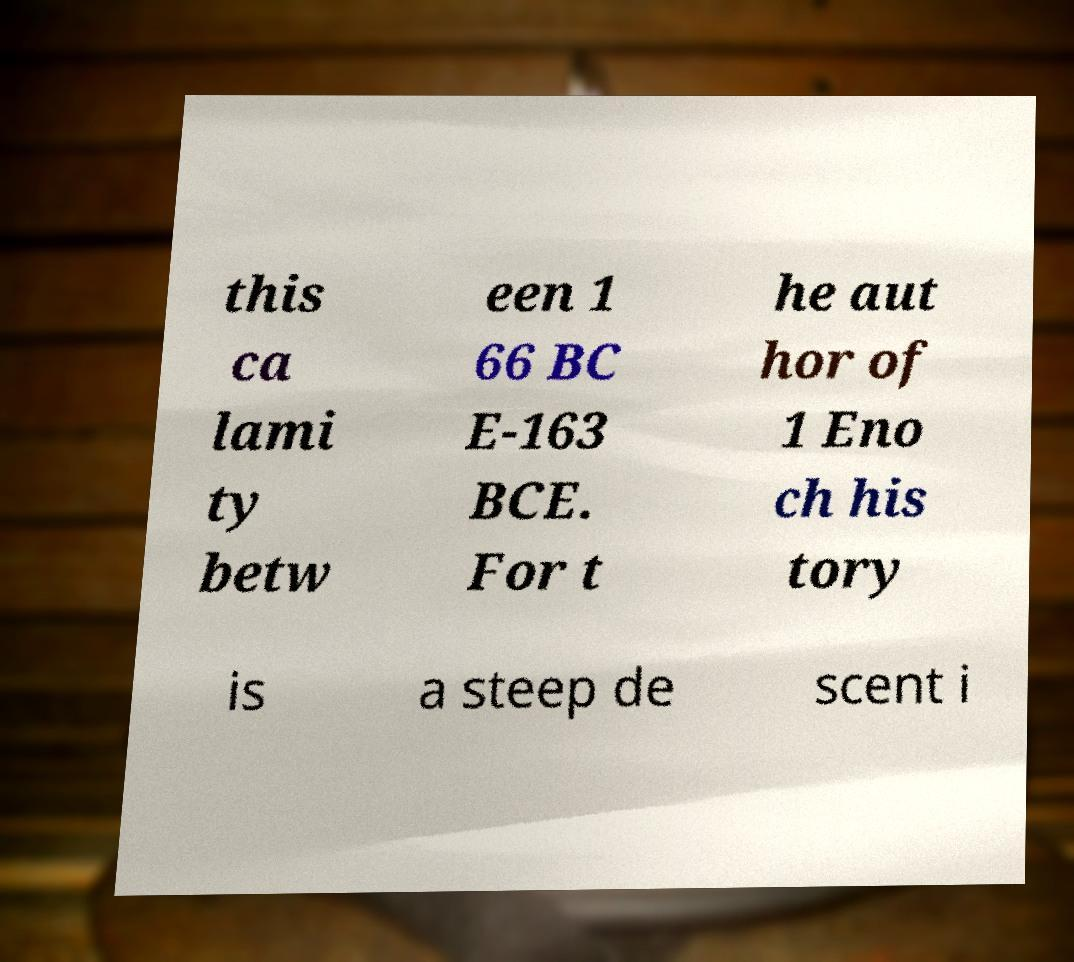Could you assist in decoding the text presented in this image and type it out clearly? this ca lami ty betw een 1 66 BC E-163 BCE. For t he aut hor of 1 Eno ch his tory is a steep de scent i 